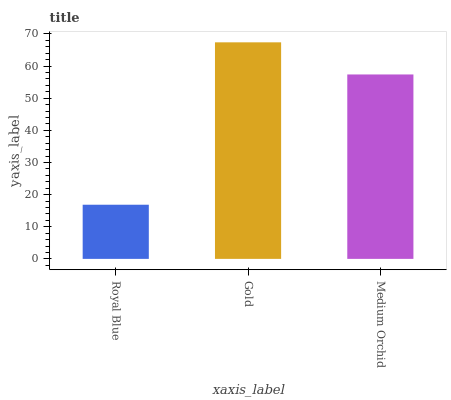Is Royal Blue the minimum?
Answer yes or no. Yes. Is Gold the maximum?
Answer yes or no. Yes. Is Medium Orchid the minimum?
Answer yes or no. No. Is Medium Orchid the maximum?
Answer yes or no. No. Is Gold greater than Medium Orchid?
Answer yes or no. Yes. Is Medium Orchid less than Gold?
Answer yes or no. Yes. Is Medium Orchid greater than Gold?
Answer yes or no. No. Is Gold less than Medium Orchid?
Answer yes or no. No. Is Medium Orchid the high median?
Answer yes or no. Yes. Is Medium Orchid the low median?
Answer yes or no. Yes. Is Gold the high median?
Answer yes or no. No. Is Royal Blue the low median?
Answer yes or no. No. 